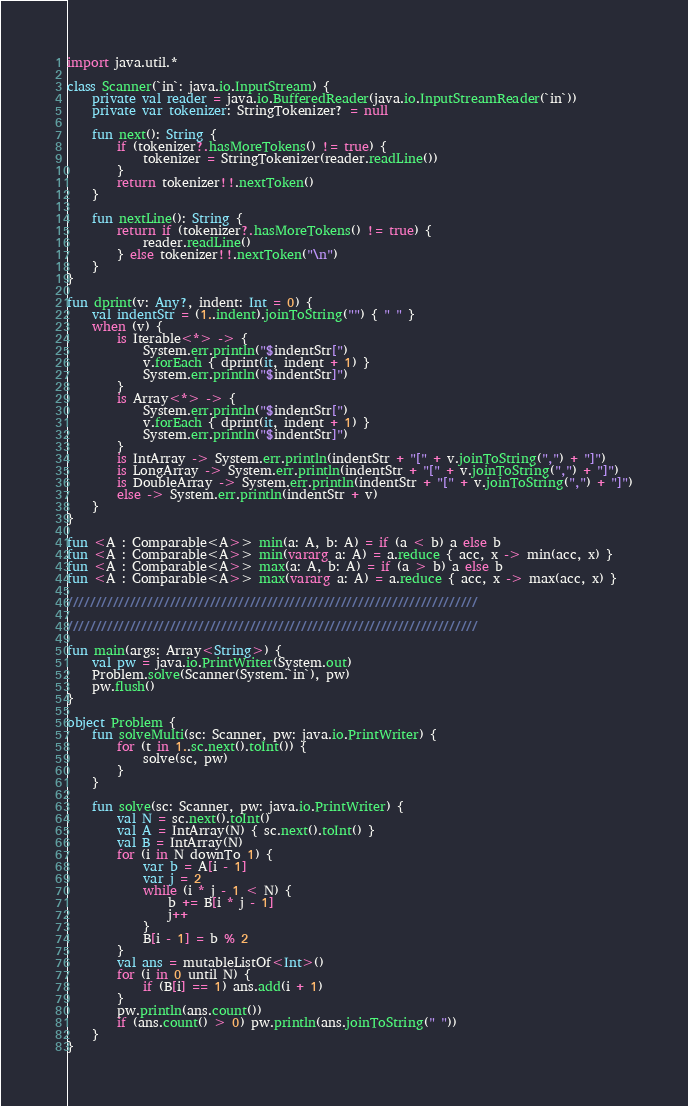Convert code to text. <code><loc_0><loc_0><loc_500><loc_500><_Kotlin_>import java.util.*

class Scanner(`in`: java.io.InputStream) {
    private val reader = java.io.BufferedReader(java.io.InputStreamReader(`in`))
    private var tokenizer: StringTokenizer? = null

    fun next(): String {
        if (tokenizer?.hasMoreTokens() != true) {
            tokenizer = StringTokenizer(reader.readLine())
        }
        return tokenizer!!.nextToken()
    }

    fun nextLine(): String {
        return if (tokenizer?.hasMoreTokens() != true) {
            reader.readLine()
        } else tokenizer!!.nextToken("\n")
    }
}

fun dprint(v: Any?, indent: Int = 0) {
    val indentStr = (1..indent).joinToString("") { " " }
    when (v) {
        is Iterable<*> -> {
            System.err.println("$indentStr[")
            v.forEach { dprint(it, indent + 1) }
            System.err.println("$indentStr]")
        }
        is Array<*> -> {
            System.err.println("$indentStr[")
            v.forEach { dprint(it, indent + 1) }
            System.err.println("$indentStr]")
        }
        is IntArray -> System.err.println(indentStr + "[" + v.joinToString(",") + "]")
        is LongArray -> System.err.println(indentStr + "[" + v.joinToString(",") + "]")
        is DoubleArray -> System.err.println(indentStr + "[" + v.joinToString(",") + "]")
        else -> System.err.println(indentStr + v)
    }
}

fun <A : Comparable<A>> min(a: A, b: A) = if (a < b) a else b
fun <A : Comparable<A>> min(vararg a: A) = a.reduce { acc, x -> min(acc, x) }
fun <A : Comparable<A>> max(a: A, b: A) = if (a > b) a else b
fun <A : Comparable<A>> max(vararg a: A) = a.reduce { acc, x -> max(acc, x) }

////////////////////////////////////////////////////////////////////////

////////////////////////////////////////////////////////////////////////

fun main(args: Array<String>) {
    val pw = java.io.PrintWriter(System.out)
    Problem.solve(Scanner(System.`in`), pw)
    pw.flush()
}

object Problem {
    fun solveMulti(sc: Scanner, pw: java.io.PrintWriter) {
        for (t in 1..sc.next().toInt()) {
            solve(sc, pw)
        }
    }

    fun solve(sc: Scanner, pw: java.io.PrintWriter) {
        val N = sc.next().toInt()
        val A = IntArray(N) { sc.next().toInt() }
        val B = IntArray(N)
        for (i in N downTo 1) {
            var b = A[i - 1]
            var j = 2
            while (i * j - 1 < N) {
                b += B[i * j - 1]
                j++
            }
            B[i - 1] = b % 2
        }
        val ans = mutableListOf<Int>()
        for (i in 0 until N) {
            if (B[i] == 1) ans.add(i + 1)
        }
        pw.println(ans.count())
        if (ans.count() > 0) pw.println(ans.joinToString(" "))
    }
}
</code> 